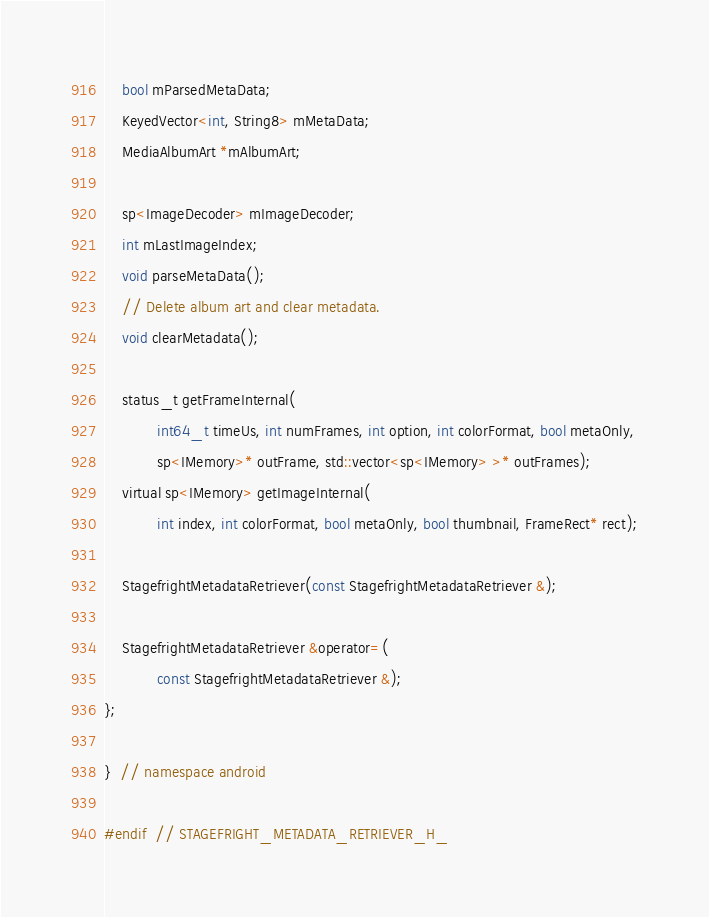<code> <loc_0><loc_0><loc_500><loc_500><_C_>
    bool mParsedMetaData;
    KeyedVector<int, String8> mMetaData;
    MediaAlbumArt *mAlbumArt;

    sp<ImageDecoder> mImageDecoder;
    int mLastImageIndex;
    void parseMetaData();
    // Delete album art and clear metadata.
    void clearMetadata();

    status_t getFrameInternal(
            int64_t timeUs, int numFrames, int option, int colorFormat, bool metaOnly,
            sp<IMemory>* outFrame, std::vector<sp<IMemory> >* outFrames);
    virtual sp<IMemory> getImageInternal(
            int index, int colorFormat, bool metaOnly, bool thumbnail, FrameRect* rect);

    StagefrightMetadataRetriever(const StagefrightMetadataRetriever &);

    StagefrightMetadataRetriever &operator=(
            const StagefrightMetadataRetriever &);
};

}  // namespace android

#endif  // STAGEFRIGHT_METADATA_RETRIEVER_H_
</code> 